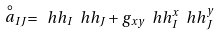Convert formula to latex. <formula><loc_0><loc_0><loc_500><loc_500>\stackrel { \circ } { a } _ { I J } = \ h h _ { I } \ h h _ { J } + g _ { x y } \ h h _ { I } ^ { x } \ h h _ { J } ^ { y }</formula> 